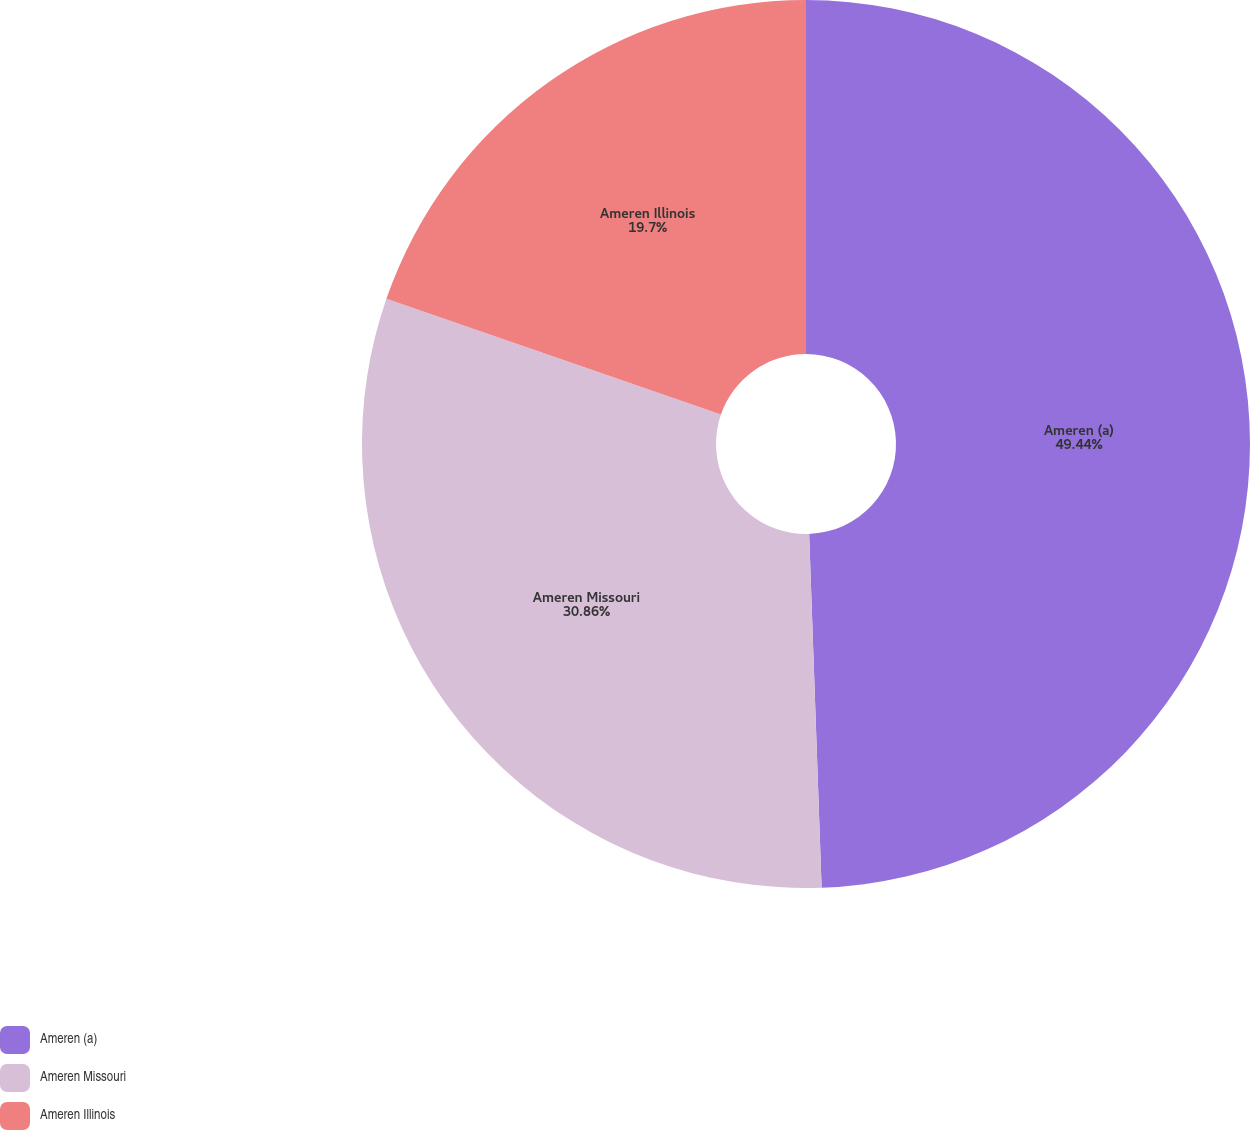Convert chart. <chart><loc_0><loc_0><loc_500><loc_500><pie_chart><fcel>Ameren (a)<fcel>Ameren Missouri<fcel>Ameren Illinois<nl><fcel>49.44%<fcel>30.86%<fcel>19.7%<nl></chart> 